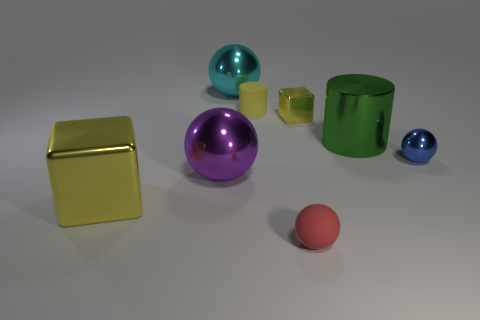Add 1 big cyan metal spheres. How many objects exist? 9 Subtract all cylinders. How many objects are left? 6 Subtract 0 brown cylinders. How many objects are left? 8 Subtract all large green rubber cylinders. Subtract all red things. How many objects are left? 7 Add 1 green shiny cylinders. How many green shiny cylinders are left? 2 Add 3 shiny spheres. How many shiny spheres exist? 6 